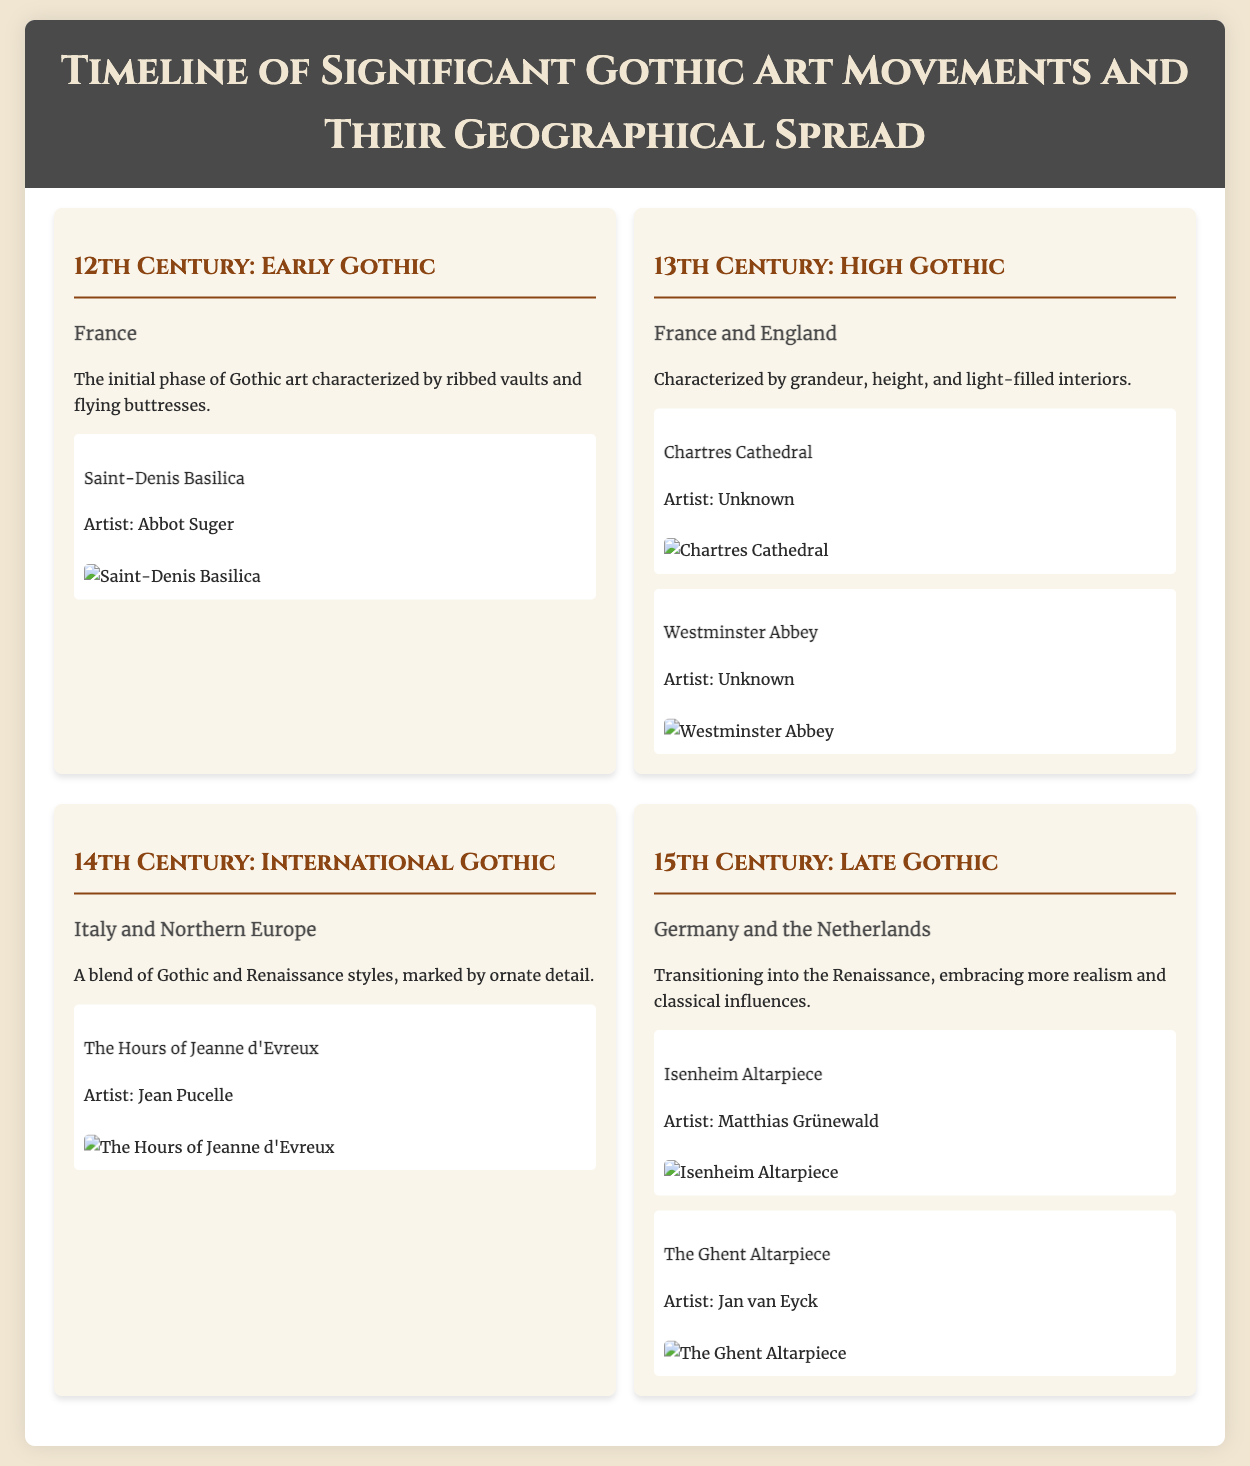What is the first significant Gothic art movement? The document specifies the first significant Gothic art movement as the Early Gothic, which emerged in the 12th Century.
Answer: Early Gothic Where is the Chartres Cathedral located? The document states that the Chartres Cathedral is located in France as part of the High Gothic movement in the 13th Century.
Answer: France Who is the artist of the Isenheim Altarpiece? The document provides the name of the artist for the Isenheim Altarpiece in the Late Gothic section as Matthias Grünewald.
Answer: Matthias Grünewald What time period does the International Gothic movement belong to? The document indicates that the International Gothic movement occurred in the 14th Century.
Answer: 14th Century What is a key characteristic of the High Gothic movement? The document describes the High Gothic movement as characterized by grandeur, height, and light-filled interiors.
Answer: Grandeur, height, and light-filled interiors How many artworks are listed under the 15th Century: Late Gothic section? The document includes two artworks listed under the Late Gothic section.
Answer: Two Which geographical regions are highlighted in the Late Gothic movement? The document highlights Germany and the Netherlands as the geographical regions of the Late Gothic movement.
Answer: Germany and the Netherlands What type of document is this? The document is a timeline that details significant Gothic art movements along with their geographical spread and major artworks.
Answer: Timeline Who created The Hours of Jeanne d'Evreux? The document attributes The Hours of Jeanne d'Evreux to the artist Jean Pucelle.
Answer: Jean Pucelle 